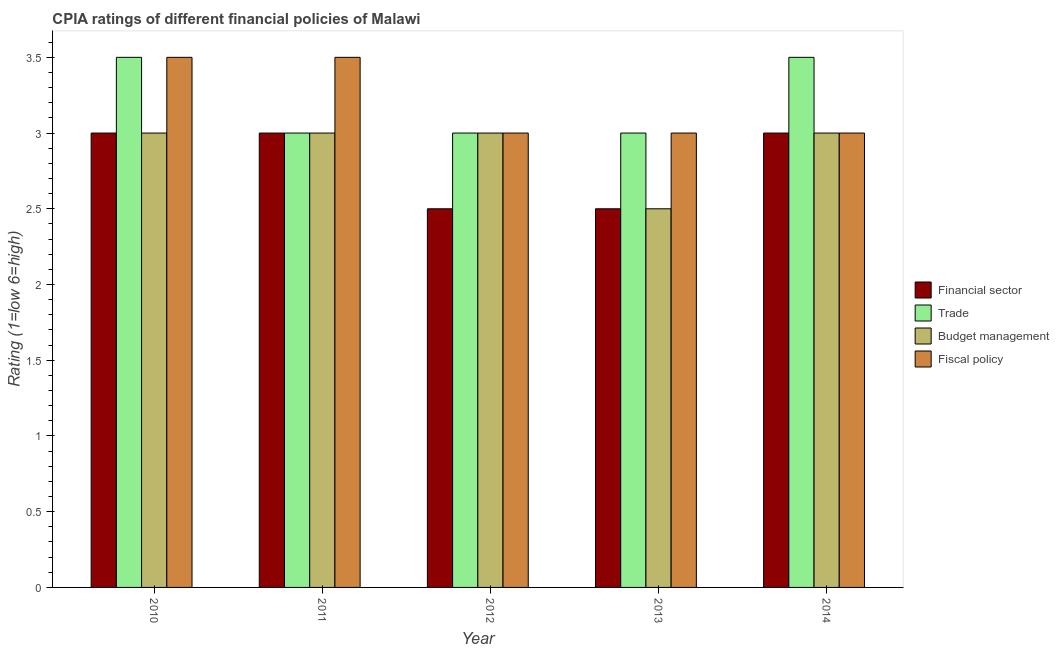How many groups of bars are there?
Your response must be concise. 5. Are the number of bars per tick equal to the number of legend labels?
Provide a short and direct response. Yes. How many bars are there on the 1st tick from the left?
Provide a short and direct response. 4. What is the label of the 5th group of bars from the left?
Make the answer very short. 2014. Across all years, what is the maximum cpia rating of budget management?
Provide a succinct answer. 3. Across all years, what is the minimum cpia rating of financial sector?
Your answer should be very brief. 2.5. What is the difference between the cpia rating of trade in 2014 and the cpia rating of financial sector in 2012?
Your answer should be compact. 0.5. In the year 2010, what is the difference between the cpia rating of fiscal policy and cpia rating of financial sector?
Make the answer very short. 0. In how many years, is the cpia rating of budget management greater than 3?
Offer a very short reply. 0. What is the ratio of the cpia rating of budget management in 2013 to that in 2014?
Offer a very short reply. 0.83. Is the cpia rating of financial sector in 2013 less than that in 2014?
Ensure brevity in your answer.  Yes. Is the difference between the cpia rating of trade in 2010 and 2011 greater than the difference between the cpia rating of financial sector in 2010 and 2011?
Provide a succinct answer. No. Is it the case that in every year, the sum of the cpia rating of fiscal policy and cpia rating of financial sector is greater than the sum of cpia rating of budget management and cpia rating of trade?
Provide a short and direct response. No. What does the 3rd bar from the left in 2012 represents?
Give a very brief answer. Budget management. What does the 2nd bar from the right in 2012 represents?
Your answer should be very brief. Budget management. Are all the bars in the graph horizontal?
Ensure brevity in your answer.  No. How many years are there in the graph?
Offer a terse response. 5. What is the difference between two consecutive major ticks on the Y-axis?
Make the answer very short. 0.5. Does the graph contain any zero values?
Keep it short and to the point. No. How many legend labels are there?
Provide a succinct answer. 4. How are the legend labels stacked?
Provide a short and direct response. Vertical. What is the title of the graph?
Your answer should be compact. CPIA ratings of different financial policies of Malawi. What is the label or title of the X-axis?
Offer a very short reply. Year. What is the label or title of the Y-axis?
Your answer should be very brief. Rating (1=low 6=high). What is the Rating (1=low 6=high) of Financial sector in 2010?
Keep it short and to the point. 3. What is the Rating (1=low 6=high) of Trade in 2010?
Ensure brevity in your answer.  3.5. What is the Rating (1=low 6=high) of Fiscal policy in 2010?
Provide a short and direct response. 3.5. What is the Rating (1=low 6=high) of Trade in 2011?
Your answer should be very brief. 3. What is the Rating (1=low 6=high) of Fiscal policy in 2011?
Make the answer very short. 3.5. What is the Rating (1=low 6=high) in Trade in 2012?
Your answer should be very brief. 3. What is the Rating (1=low 6=high) of Trade in 2013?
Make the answer very short. 3. What is the Rating (1=low 6=high) of Fiscal policy in 2013?
Offer a very short reply. 3. Across all years, what is the maximum Rating (1=low 6=high) of Financial sector?
Give a very brief answer. 3. Across all years, what is the maximum Rating (1=low 6=high) in Trade?
Your answer should be very brief. 3.5. Across all years, what is the maximum Rating (1=low 6=high) in Fiscal policy?
Keep it short and to the point. 3.5. Across all years, what is the minimum Rating (1=low 6=high) of Financial sector?
Give a very brief answer. 2.5. Across all years, what is the minimum Rating (1=low 6=high) of Trade?
Provide a short and direct response. 3. Across all years, what is the minimum Rating (1=low 6=high) of Budget management?
Your answer should be compact. 2.5. What is the difference between the Rating (1=low 6=high) of Budget management in 2010 and that in 2012?
Keep it short and to the point. 0. What is the difference between the Rating (1=low 6=high) of Fiscal policy in 2010 and that in 2012?
Provide a succinct answer. 0.5. What is the difference between the Rating (1=low 6=high) in Financial sector in 2010 and that in 2013?
Give a very brief answer. 0.5. What is the difference between the Rating (1=low 6=high) in Fiscal policy in 2010 and that in 2013?
Your answer should be very brief. 0.5. What is the difference between the Rating (1=low 6=high) of Fiscal policy in 2010 and that in 2014?
Ensure brevity in your answer.  0.5. What is the difference between the Rating (1=low 6=high) of Budget management in 2011 and that in 2012?
Provide a succinct answer. 0. What is the difference between the Rating (1=low 6=high) in Fiscal policy in 2011 and that in 2012?
Your response must be concise. 0.5. What is the difference between the Rating (1=low 6=high) in Financial sector in 2011 and that in 2013?
Offer a very short reply. 0.5. What is the difference between the Rating (1=low 6=high) in Trade in 2011 and that in 2013?
Your response must be concise. 0. What is the difference between the Rating (1=low 6=high) in Budget management in 2011 and that in 2013?
Your answer should be very brief. 0.5. What is the difference between the Rating (1=low 6=high) of Financial sector in 2011 and that in 2014?
Offer a very short reply. 0. What is the difference between the Rating (1=low 6=high) of Budget management in 2011 and that in 2014?
Offer a terse response. 0. What is the difference between the Rating (1=low 6=high) of Trade in 2012 and that in 2013?
Ensure brevity in your answer.  0. What is the difference between the Rating (1=low 6=high) of Financial sector in 2012 and that in 2014?
Provide a succinct answer. -0.5. What is the difference between the Rating (1=low 6=high) of Budget management in 2012 and that in 2014?
Your response must be concise. 0. What is the difference between the Rating (1=low 6=high) of Fiscal policy in 2012 and that in 2014?
Offer a terse response. 0. What is the difference between the Rating (1=low 6=high) of Trade in 2013 and that in 2014?
Your answer should be very brief. -0.5. What is the difference between the Rating (1=low 6=high) of Fiscal policy in 2013 and that in 2014?
Provide a succinct answer. 0. What is the difference between the Rating (1=low 6=high) of Financial sector in 2010 and the Rating (1=low 6=high) of Fiscal policy in 2011?
Offer a terse response. -0.5. What is the difference between the Rating (1=low 6=high) of Trade in 2010 and the Rating (1=low 6=high) of Budget management in 2011?
Offer a terse response. 0.5. What is the difference between the Rating (1=low 6=high) of Trade in 2010 and the Rating (1=low 6=high) of Fiscal policy in 2011?
Offer a very short reply. 0. What is the difference between the Rating (1=low 6=high) of Budget management in 2010 and the Rating (1=low 6=high) of Fiscal policy in 2011?
Your response must be concise. -0.5. What is the difference between the Rating (1=low 6=high) in Financial sector in 2010 and the Rating (1=low 6=high) in Fiscal policy in 2012?
Offer a terse response. 0. What is the difference between the Rating (1=low 6=high) of Trade in 2010 and the Rating (1=low 6=high) of Fiscal policy in 2012?
Provide a short and direct response. 0.5. What is the difference between the Rating (1=low 6=high) of Budget management in 2010 and the Rating (1=low 6=high) of Fiscal policy in 2012?
Your answer should be very brief. 0. What is the difference between the Rating (1=low 6=high) in Financial sector in 2010 and the Rating (1=low 6=high) in Trade in 2013?
Offer a very short reply. 0. What is the difference between the Rating (1=low 6=high) of Financial sector in 2010 and the Rating (1=low 6=high) of Budget management in 2013?
Offer a very short reply. 0.5. What is the difference between the Rating (1=low 6=high) in Financial sector in 2010 and the Rating (1=low 6=high) in Fiscal policy in 2013?
Provide a succinct answer. 0. What is the difference between the Rating (1=low 6=high) in Budget management in 2010 and the Rating (1=low 6=high) in Fiscal policy in 2013?
Give a very brief answer. 0. What is the difference between the Rating (1=low 6=high) in Financial sector in 2010 and the Rating (1=low 6=high) in Budget management in 2014?
Provide a short and direct response. 0. What is the difference between the Rating (1=low 6=high) in Trade in 2010 and the Rating (1=low 6=high) in Fiscal policy in 2014?
Ensure brevity in your answer.  0.5. What is the difference between the Rating (1=low 6=high) of Financial sector in 2011 and the Rating (1=low 6=high) of Trade in 2012?
Provide a short and direct response. 0. What is the difference between the Rating (1=low 6=high) of Financial sector in 2011 and the Rating (1=low 6=high) of Budget management in 2012?
Ensure brevity in your answer.  0. What is the difference between the Rating (1=low 6=high) in Financial sector in 2011 and the Rating (1=low 6=high) in Fiscal policy in 2012?
Offer a very short reply. 0. What is the difference between the Rating (1=low 6=high) of Financial sector in 2011 and the Rating (1=low 6=high) of Budget management in 2013?
Ensure brevity in your answer.  0.5. What is the difference between the Rating (1=low 6=high) in Financial sector in 2011 and the Rating (1=low 6=high) in Fiscal policy in 2013?
Provide a short and direct response. 0. What is the difference between the Rating (1=low 6=high) of Trade in 2011 and the Rating (1=low 6=high) of Fiscal policy in 2013?
Provide a succinct answer. 0. What is the difference between the Rating (1=low 6=high) of Financial sector in 2011 and the Rating (1=low 6=high) of Budget management in 2014?
Your answer should be compact. 0. What is the difference between the Rating (1=low 6=high) of Financial sector in 2011 and the Rating (1=low 6=high) of Fiscal policy in 2014?
Keep it short and to the point. 0. What is the difference between the Rating (1=low 6=high) of Financial sector in 2012 and the Rating (1=low 6=high) of Budget management in 2013?
Provide a short and direct response. 0. What is the difference between the Rating (1=low 6=high) of Trade in 2012 and the Rating (1=low 6=high) of Fiscal policy in 2013?
Provide a short and direct response. 0. What is the difference between the Rating (1=low 6=high) of Budget management in 2012 and the Rating (1=low 6=high) of Fiscal policy in 2013?
Your answer should be compact. 0. What is the difference between the Rating (1=low 6=high) of Financial sector in 2012 and the Rating (1=low 6=high) of Trade in 2014?
Offer a very short reply. -1. What is the difference between the Rating (1=low 6=high) in Financial sector in 2012 and the Rating (1=low 6=high) in Fiscal policy in 2014?
Ensure brevity in your answer.  -0.5. What is the difference between the Rating (1=low 6=high) in Trade in 2012 and the Rating (1=low 6=high) in Budget management in 2014?
Offer a terse response. 0. What is the difference between the Rating (1=low 6=high) in Trade in 2012 and the Rating (1=low 6=high) in Fiscal policy in 2014?
Your answer should be very brief. 0. What is the difference between the Rating (1=low 6=high) in Budget management in 2012 and the Rating (1=low 6=high) in Fiscal policy in 2014?
Keep it short and to the point. 0. What is the difference between the Rating (1=low 6=high) of Financial sector in 2013 and the Rating (1=low 6=high) of Trade in 2014?
Your answer should be very brief. -1. What is the average Rating (1=low 6=high) of Budget management per year?
Provide a short and direct response. 2.9. What is the average Rating (1=low 6=high) of Fiscal policy per year?
Keep it short and to the point. 3.2. In the year 2010, what is the difference between the Rating (1=low 6=high) in Financial sector and Rating (1=low 6=high) in Fiscal policy?
Your response must be concise. -0.5. In the year 2010, what is the difference between the Rating (1=low 6=high) of Trade and Rating (1=low 6=high) of Budget management?
Offer a very short reply. 0.5. In the year 2011, what is the difference between the Rating (1=low 6=high) of Financial sector and Rating (1=low 6=high) of Trade?
Provide a succinct answer. 0. In the year 2011, what is the difference between the Rating (1=low 6=high) in Financial sector and Rating (1=low 6=high) in Budget management?
Keep it short and to the point. 0. In the year 2011, what is the difference between the Rating (1=low 6=high) of Financial sector and Rating (1=low 6=high) of Fiscal policy?
Your response must be concise. -0.5. In the year 2012, what is the difference between the Rating (1=low 6=high) of Financial sector and Rating (1=low 6=high) of Trade?
Offer a terse response. -0.5. In the year 2012, what is the difference between the Rating (1=low 6=high) of Financial sector and Rating (1=low 6=high) of Budget management?
Give a very brief answer. -0.5. In the year 2012, what is the difference between the Rating (1=low 6=high) of Financial sector and Rating (1=low 6=high) of Fiscal policy?
Ensure brevity in your answer.  -0.5. In the year 2012, what is the difference between the Rating (1=low 6=high) of Trade and Rating (1=low 6=high) of Fiscal policy?
Make the answer very short. 0. In the year 2013, what is the difference between the Rating (1=low 6=high) of Financial sector and Rating (1=low 6=high) of Budget management?
Ensure brevity in your answer.  0. In the year 2013, what is the difference between the Rating (1=low 6=high) of Trade and Rating (1=low 6=high) of Budget management?
Give a very brief answer. 0.5. In the year 2013, what is the difference between the Rating (1=low 6=high) in Trade and Rating (1=low 6=high) in Fiscal policy?
Ensure brevity in your answer.  0. In the year 2014, what is the difference between the Rating (1=low 6=high) in Financial sector and Rating (1=low 6=high) in Fiscal policy?
Your answer should be very brief. 0. In the year 2014, what is the difference between the Rating (1=low 6=high) of Budget management and Rating (1=low 6=high) of Fiscal policy?
Offer a very short reply. 0. What is the ratio of the Rating (1=low 6=high) of Financial sector in 2010 to that in 2011?
Make the answer very short. 1. What is the ratio of the Rating (1=low 6=high) in Trade in 2010 to that in 2011?
Offer a terse response. 1.17. What is the ratio of the Rating (1=low 6=high) of Fiscal policy in 2010 to that in 2011?
Make the answer very short. 1. What is the ratio of the Rating (1=low 6=high) of Trade in 2010 to that in 2012?
Keep it short and to the point. 1.17. What is the ratio of the Rating (1=low 6=high) of Budget management in 2010 to that in 2012?
Keep it short and to the point. 1. What is the ratio of the Rating (1=low 6=high) of Financial sector in 2010 to that in 2013?
Your answer should be very brief. 1.2. What is the ratio of the Rating (1=low 6=high) of Budget management in 2010 to that in 2013?
Offer a very short reply. 1.2. What is the ratio of the Rating (1=low 6=high) of Budget management in 2010 to that in 2014?
Make the answer very short. 1. What is the ratio of the Rating (1=low 6=high) of Financial sector in 2011 to that in 2012?
Give a very brief answer. 1.2. What is the ratio of the Rating (1=low 6=high) in Budget management in 2011 to that in 2012?
Offer a very short reply. 1. What is the ratio of the Rating (1=low 6=high) in Financial sector in 2011 to that in 2013?
Your answer should be very brief. 1.2. What is the ratio of the Rating (1=low 6=high) in Financial sector in 2011 to that in 2014?
Your response must be concise. 1. What is the ratio of the Rating (1=low 6=high) in Budget management in 2011 to that in 2014?
Give a very brief answer. 1. What is the ratio of the Rating (1=low 6=high) of Trade in 2012 to that in 2014?
Give a very brief answer. 0.86. What is the ratio of the Rating (1=low 6=high) of Budget management in 2012 to that in 2014?
Provide a short and direct response. 1. What is the ratio of the Rating (1=low 6=high) of Fiscal policy in 2012 to that in 2014?
Give a very brief answer. 1. What is the ratio of the Rating (1=low 6=high) of Trade in 2013 to that in 2014?
Offer a very short reply. 0.86. What is the ratio of the Rating (1=low 6=high) of Fiscal policy in 2013 to that in 2014?
Your response must be concise. 1. What is the difference between the highest and the second highest Rating (1=low 6=high) in Trade?
Make the answer very short. 0. What is the difference between the highest and the second highest Rating (1=low 6=high) of Fiscal policy?
Make the answer very short. 0. What is the difference between the highest and the lowest Rating (1=low 6=high) in Trade?
Your answer should be very brief. 0.5. What is the difference between the highest and the lowest Rating (1=low 6=high) of Budget management?
Keep it short and to the point. 0.5. 